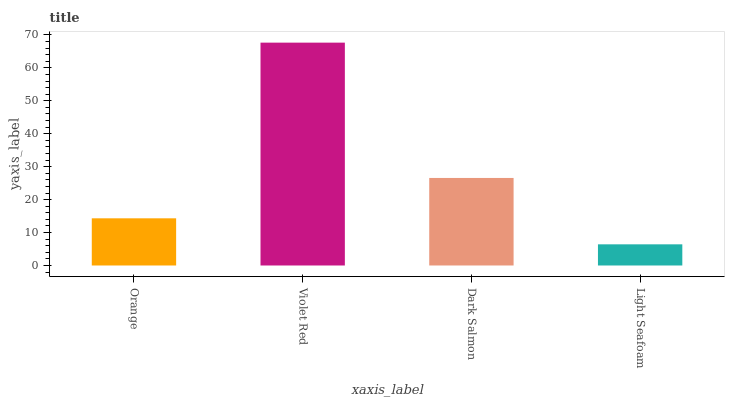Is Light Seafoam the minimum?
Answer yes or no. Yes. Is Violet Red the maximum?
Answer yes or no. Yes. Is Dark Salmon the minimum?
Answer yes or no. No. Is Dark Salmon the maximum?
Answer yes or no. No. Is Violet Red greater than Dark Salmon?
Answer yes or no. Yes. Is Dark Salmon less than Violet Red?
Answer yes or no. Yes. Is Dark Salmon greater than Violet Red?
Answer yes or no. No. Is Violet Red less than Dark Salmon?
Answer yes or no. No. Is Dark Salmon the high median?
Answer yes or no. Yes. Is Orange the low median?
Answer yes or no. Yes. Is Orange the high median?
Answer yes or no. No. Is Light Seafoam the low median?
Answer yes or no. No. 